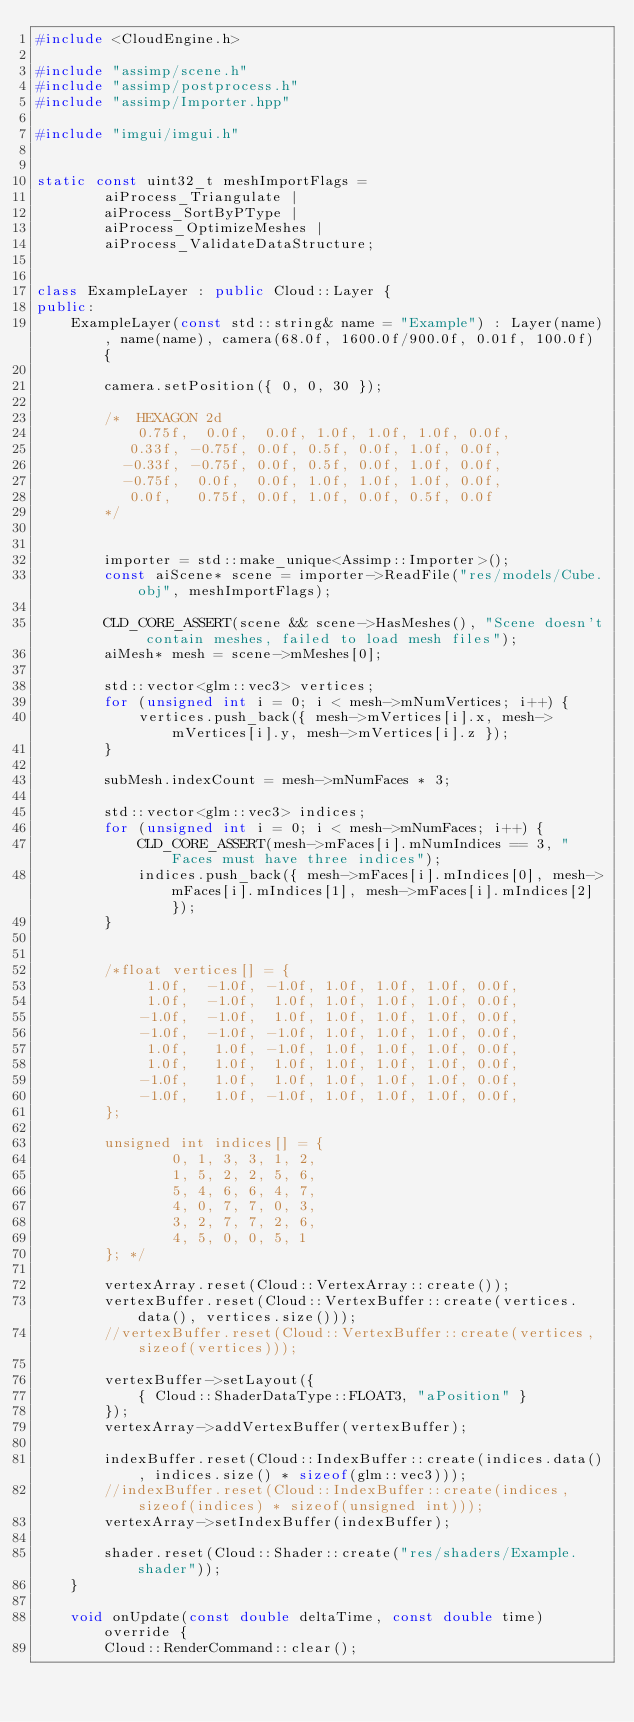<code> <loc_0><loc_0><loc_500><loc_500><_C++_>#include <CloudEngine.h>

#include "assimp/scene.h"
#include "assimp/postprocess.h"
#include "assimp/Importer.hpp"

#include "imgui/imgui.h"


static const uint32_t meshImportFlags =
		aiProcess_Triangulate |
		aiProcess_SortByPType |
		aiProcess_OptimizeMeshes |
		aiProcess_ValidateDataStructure;


class ExampleLayer : public Cloud::Layer {
public:
	ExampleLayer(const std::string& name = "Example") : Layer(name), name(name), camera(68.0f, 1600.0f/900.0f, 0.01f, 100.0f) {

		camera.setPosition({ 0, 0, 30 });
		
		/*	HEXAGON 2d
			0.75f,  0.0f,  0.0f, 1.0f, 1.0f, 1.0f, 0.0f,
		   0.33f, -0.75f, 0.0f, 0.5f, 0.0f, 1.0f, 0.0f,
		  -0.33f, -0.75f, 0.0f, 0.5f, 0.0f, 1.0f, 0.0f,
		  -0.75f,  0.0f,  0.0f, 1.0f, 1.0f, 1.0f, 0.0f,
		   0.0f,   0.75f, 0.0f, 1.0f, 0.0f, 0.5f, 0.0f
		*/


		importer = std::make_unique<Assimp::Importer>();
		const aiScene* scene = importer->ReadFile("res/models/Cube.obj", meshImportFlags);

		CLD_CORE_ASSERT(scene && scene->HasMeshes(), "Scene doesn't contain meshes, failed to load mesh files");
		aiMesh* mesh = scene->mMeshes[0];

		std::vector<glm::vec3> vertices;
		for (unsigned int i = 0; i < mesh->mNumVertices; i++) {
			vertices.push_back({ mesh->mVertices[i].x, mesh->mVertices[i].y, mesh->mVertices[i].z });
		}
		
		subMesh.indexCount = mesh->mNumFaces * 3;
		
		std::vector<glm::vec3> indices;
		for (unsigned int i = 0; i < mesh->mNumFaces; i++) {
			CLD_CORE_ASSERT(mesh->mFaces[i].mNumIndices == 3, "Faces must have three indices");
			indices.push_back({ mesh->mFaces[i].mIndices[0], mesh->mFaces[i].mIndices[1], mesh->mFaces[i].mIndices[2] });
		}

		
		/*float vertices[] = {
			 1.0f,  -1.0f, -1.0f, 1.0f, 1.0f, 1.0f, 0.0f,
			 1.0f,  -1.0f,  1.0f, 1.0f, 1.0f, 1.0f, 0.0f,
			-1.0f,  -1.0f,  1.0f, 1.0f, 1.0f, 1.0f, 0.0f,
			-1.0f,  -1.0f, -1.0f, 1.0f, 1.0f, 1.0f, 0.0f,
			 1.0f,   1.0f, -1.0f, 1.0f, 1.0f, 1.0f, 0.0f,
			 1.0f,   1.0f,  1.0f, 1.0f, 1.0f, 1.0f, 0.0f,
			-1.0f,   1.0f,  1.0f, 1.0f, 1.0f, 1.0f, 0.0f,
			-1.0f,   1.0f, -1.0f, 1.0f, 1.0f, 1.0f, 0.0f,
		};

		unsigned int indices[] = {
				0, 1, 3, 3, 1, 2,
				1, 5, 2, 2, 5, 6,
				5, 4, 6, 6, 4, 7,
				4, 0, 7, 7, 0, 3,
				3, 2, 7, 7, 2, 6,
				4, 5, 0, 0, 5, 1
		}; */

		vertexArray.reset(Cloud::VertexArray::create());
		vertexBuffer.reset(Cloud::VertexBuffer::create(vertices.data(), vertices.size()));
		//vertexBuffer.reset(Cloud::VertexBuffer::create(vertices, sizeof(vertices)));

		vertexBuffer->setLayout({
			{ Cloud::ShaderDataType::FLOAT3, "aPosition" }
		});
		vertexArray->addVertexBuffer(vertexBuffer);
		
		indexBuffer.reset(Cloud::IndexBuffer::create(indices.data(), indices.size() * sizeof(glm::vec3)));
		//indexBuffer.reset(Cloud::IndexBuffer::create(indices, sizeof(indices) * sizeof(unsigned int)));
		vertexArray->setIndexBuffer(indexBuffer);

		shader.reset(Cloud::Shader::create("res/shaders/Example.shader"));
	}
	
	void onUpdate(const double deltaTime, const double time) override {
		Cloud::RenderCommand::clear();</code> 